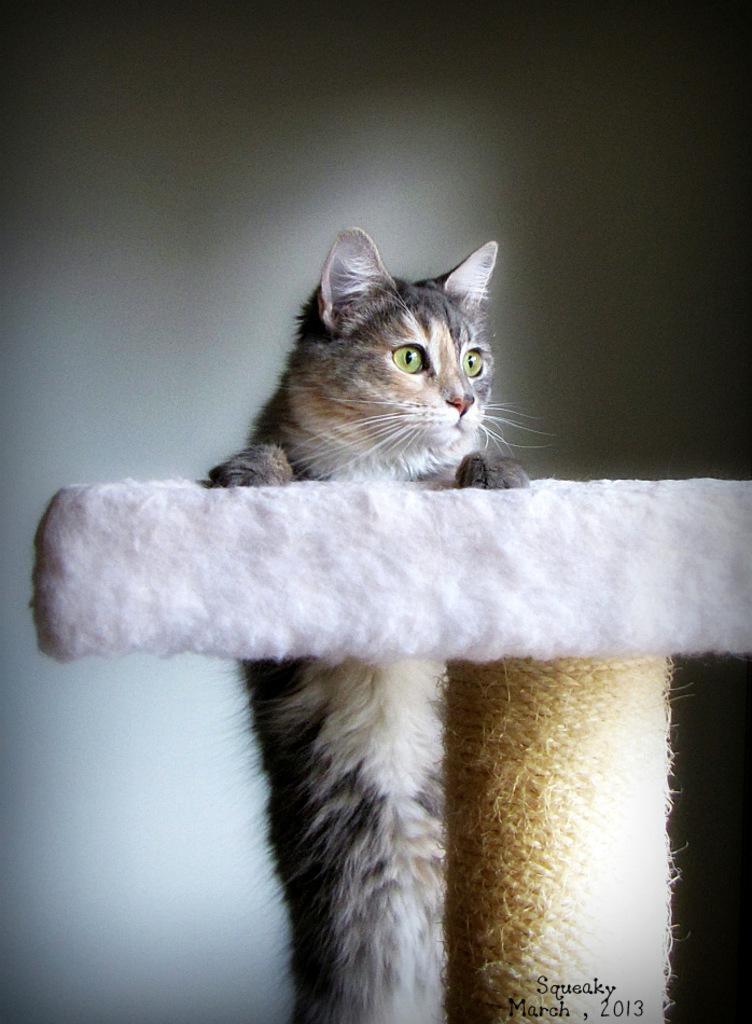Describe this image in one or two sentences. In the center of the picture there is a cat holding an object, behind the cat it is wall. 